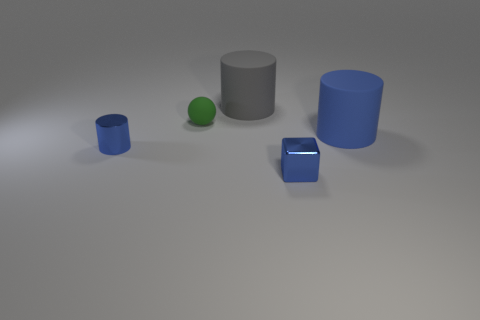Do the metallic cylinder and the large rubber cylinder that is to the left of the big blue cylinder have the same color?
Provide a short and direct response. No. There is a tiny object that is the same color as the tiny cylinder; what is it made of?
Your response must be concise. Metal. Is there anything else that has the same shape as the big blue thing?
Your answer should be compact. Yes. There is a tiny metal thing that is to the right of the large rubber cylinder that is on the left side of the large matte object in front of the large gray thing; what is its shape?
Give a very brief answer. Cube. The large blue object has what shape?
Offer a terse response. Cylinder. There is a large matte object that is in front of the small rubber ball; what color is it?
Offer a very short reply. Blue. Is the size of the cylinder that is on the left side of the green sphere the same as the sphere?
Your response must be concise. Yes. What size is the other matte object that is the same shape as the big gray matte thing?
Provide a succinct answer. Large. Is there any other thing that has the same size as the blue cube?
Keep it short and to the point. Yes. Is the gray object the same shape as the tiny green rubber thing?
Make the answer very short. No. 